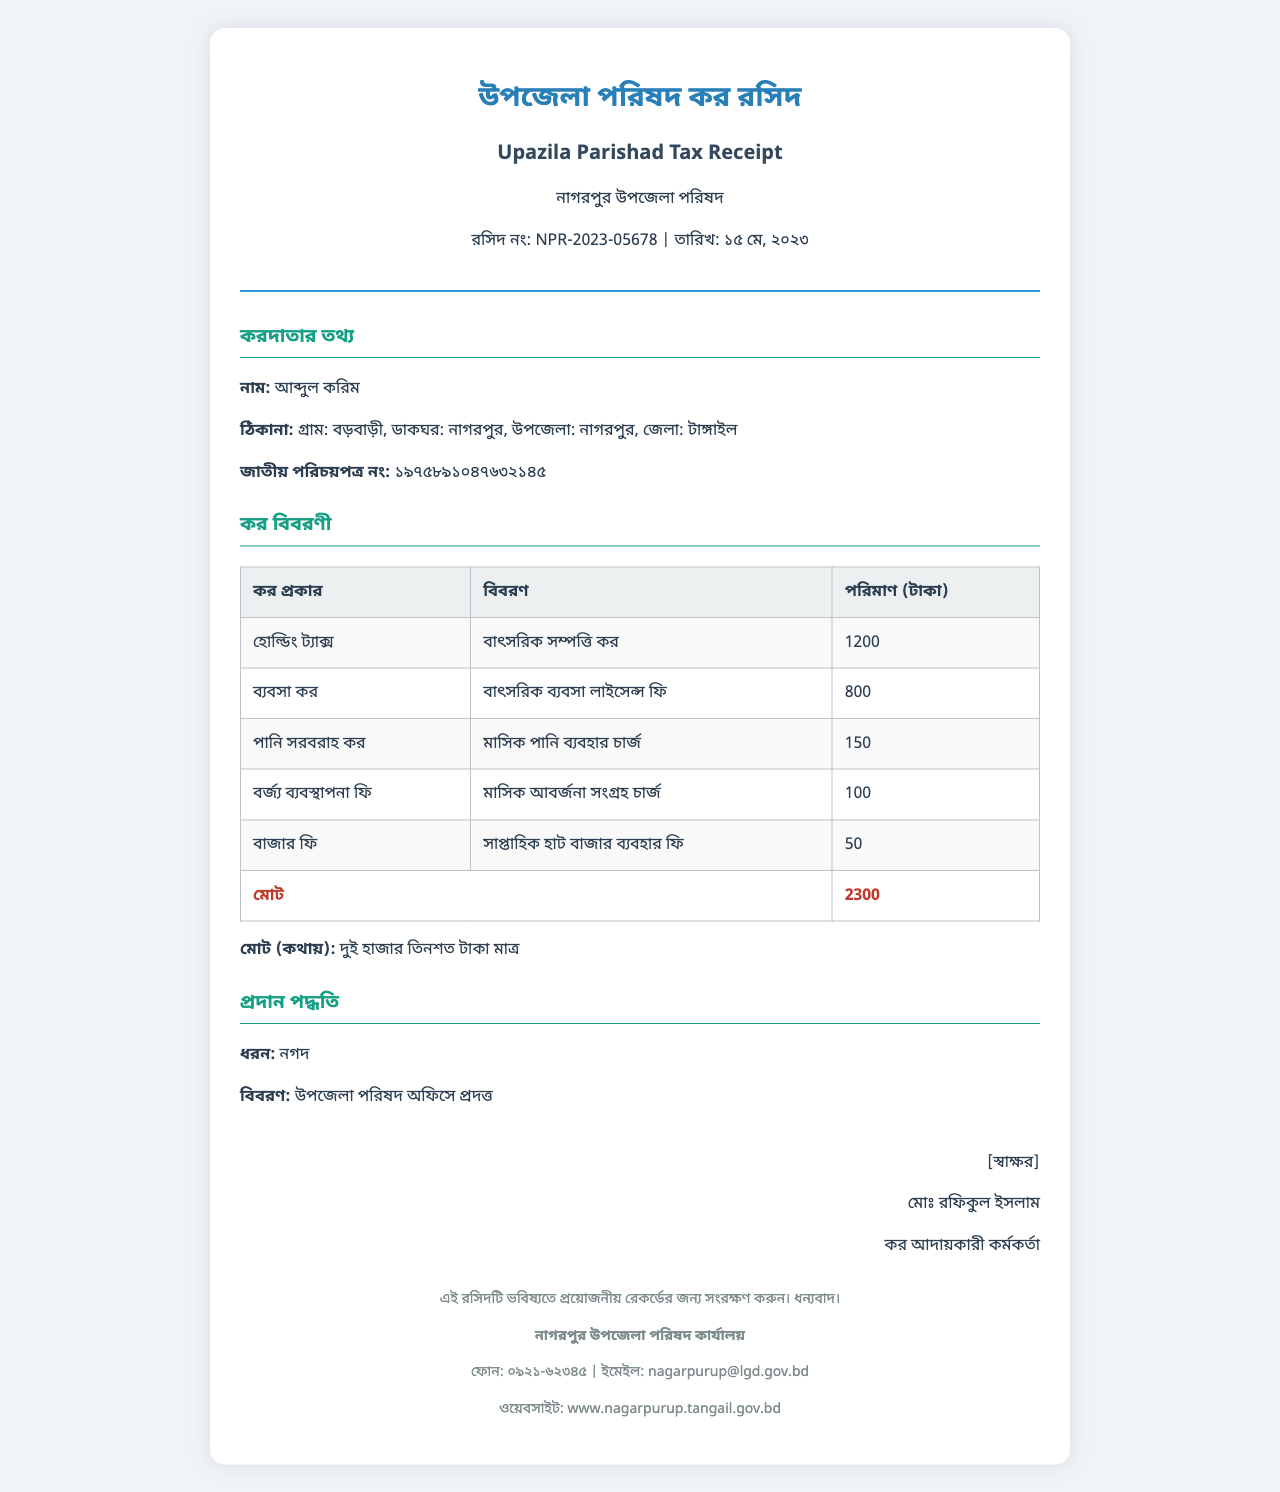What is the issuing authority? The issuing authority is the organization that provides the receipt, mentioned at the top of the document.
Answer: নাগরপুর উপজেলা পরিষদ What is the date of the receipt? The date is listed near the receipt number, indicating when the payment was made.
Answer: ১৫ মে, ২০২৩ How much is the holding tax? The amount for holding tax is provided in the tax breakdown section of the receipt.
Answer: 1200 Who is the taxpayer? The namer of the individual responsible for the payment is featured prominently in the taxpayer information section.
Answer: আব্দুল করিম What is the total amount due? The total amount is stated at the bottom of the tax breakdown, summarizing all taxes paid.
Answer: 2300 How much is charged for water supply tax? The specific amount for water supply tax is detailed under its description in the tax breakdown table.
Answer: 150 What is the authorized signatory's name? The name of the person who authorized the receipt is found in the signature section at the bottom.
Answer: মোঃ রফিকুল ইসলাম What is the payment method? The payment method is described in a section detailing how the payment was made.
Answer: নগদ How many tax types are listed? The tax breakdown section includes multiple entries, which reflect different types of taxes and fees.
Answer: 5 What should be done with this receipt? The footer note provides guidance on the retention of the receipt for future reference.
Answer: সংরক্ষণ করুন 